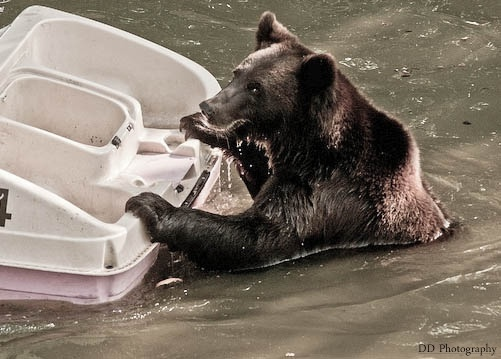Describe the objects in this image and their specific colors. I can see a bear in gray and black tones in this image. 